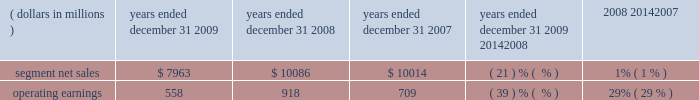Management 2019s discussion and analysis of financial condition and results of operations in 2008 , asp was flat compared to 2007 .
By comparison , asp decreased approximately 9% ( 9 % ) in 2007 and decreased approximately 11% ( 11 % ) in 2006 .
The segment has several large customers located throughout the world .
In 2008 , aggregate net sales to the segment 2019s five largest customers accounted for approximately 41% ( 41 % ) of the segment 2019s net sales .
Besides selling directly to carriers and operators , the segment also sells products through a variety of third-party distributors and retailers , which accounted for approximately 24% ( 24 % ) of the segment 2019s net sales in 2008 .
Although the u.s .
Market continued to be the segment 2019s largest individual market , many of our customers , and 56% ( 56 % ) of the segment 2019s 2008 net sales , were outside the u.s .
In 2008 , the largest of these international markets were brazil , china and mexico .
As the segment 2019s revenue transactions are largely denominated in local currencies , we are impacted by the weakening in the value of these local currencies against the u.s .
Dollar .
A number of our more significant international markets , particularly in latin america , were impacted by this trend in late 2008 .
Home and networks mobility segment the home and networks mobility segment designs , manufactures , sells , installs and services : ( i ) digital video , internet protocol video and broadcast network interactive set-tops , end-to-end video distribution systems , broadband access infrastructure platforms , and associated data and voice customer premise equipment to cable television and telecom service providers ( collectively , referred to as the 2018 2018home business 2019 2019 ) , and ( ii ) wireless access systems , including cellular infrastructure systems and wireless broadband systems , to wireless service providers ( collectively , referred to as the 2018 2018network business 2019 2019 ) .
In 2009 , the segment 2019s net sales represented 36% ( 36 % ) of the company 2019s consolidated net sales , compared to 33% ( 33 % ) in 2008 and 27% ( 27 % ) in 2007 .
Years ended december 31 percent change ( dollars in millions ) 2009 2008 2007 2009 20142008 2008 20142007 .
Segment results 20142009 compared to 2008 in 2009 , the segment 2019s net sales were $ 8.0 billion , a decrease of 21% ( 21 % ) compared to net sales of $ 10.1 billion in 2008 .
The 21% ( 21 % ) decrease in net sales reflects a 22% ( 22 % ) decrease in net sales in the networks business and a 21% ( 21 % ) decrease in net sales in the home business .
The 22% ( 22 % ) decrease in net sales in the networks business was primarily driven by lower net sales of gsm , cdma , umts and iden infrastructure equipment , partially offset by higher net sales of wimax products .
The 21% ( 21 % ) decrease in net sales in the home business was primarily driven by a 24% ( 24 % ) decrease in net sales of digital entertainment devices , reflecting : ( i ) an 18% ( 18 % ) decrease in shipments of digital entertainment devices , primarily due to lower shipments to large cable and telecommunications operators in north america as a result of macroeconomic conditions , and ( ii ) a lower asp due to an unfavorable shift in product mix .
The segment shipped 14.7 million digital entertainment devices in 2009 , compared to 18.0 million shipped in 2008 .
On a geographic basis , the 21% ( 21 % ) decrease in net sales was driven by lower net sales in all regions .
The decrease in net sales in north america was primarily due to : ( i ) lower net sales in the home business , and ( ii ) lower net sales of cdma and iden infrastructure equipment , partially offset by higher net sales of wimax products .
The decrease in net sales in emea was primarily due to lower net sales of gsm infrastructure equipment , partially offset by higher net sales of wimax products and higher net sales in the home business .
The decrease in net sales in asia was primarily driven by lower net sales of gsm , umts and cdma infrastructure equipment , partially offset by higher net sales in the home business .
The decrease in net sales in latin america was primarily due to : ( i ) lower net sales in the home business , and ( ii ) lower net sales of iden infrastructure equipment , partially offset by higher net sales of wimax products .
Net sales in north america accounted for approximately 51% ( 51 % ) of the segment 2019s total net sales in 2009 , compared to approximately 50% ( 50 % ) of the segment 2019s total net sales in 2008. .
Did consolidated net sales grow from 2007 to 2009 , and what was the growth , in a percentage , from 2007 to 2009? 
Rationale: in order to find out consolidated net sales , one must multiple the segmented net sales by the percentage given in line 4 . these numbers are subtracted by each other and the solution is divided by the lowest number . the final answer is then 6%
Computations: ((7963 * 36%) - (10014 * 27%))
Answer: 162.9. 